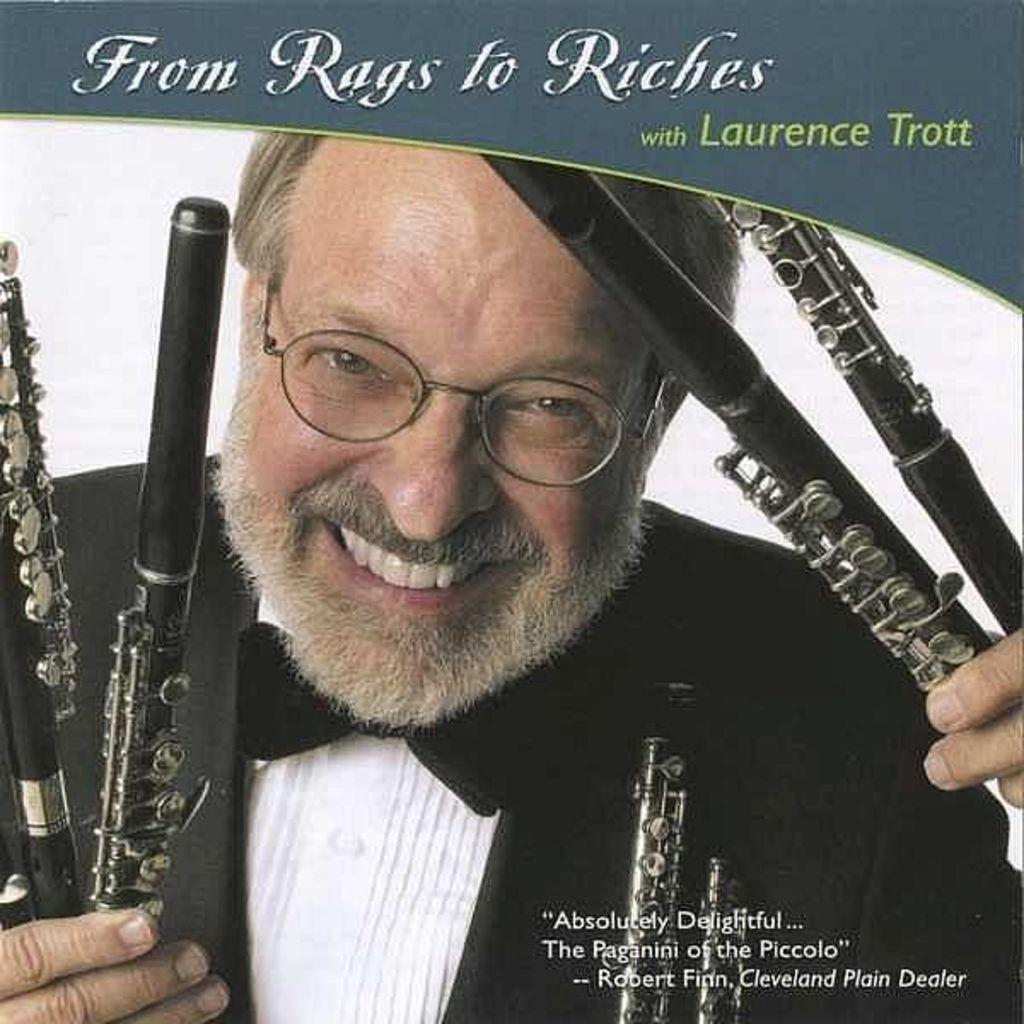What is featured on the poster in the image? There is a poster with text in the image. Can you describe the person in the image? There is a person in the image. What is the person holding in the image? The person is holding objects that resemble a musical instrument. How many family members are present in the image? There is no information about family members in the image; it only features a person holding objects that resemble a musical instrument and a poster with text. What type of power is being generated by the person in the image? There is no indication of power generation in the image; it only features a person holding objects that resemble a musical instrument and a poster with text. 